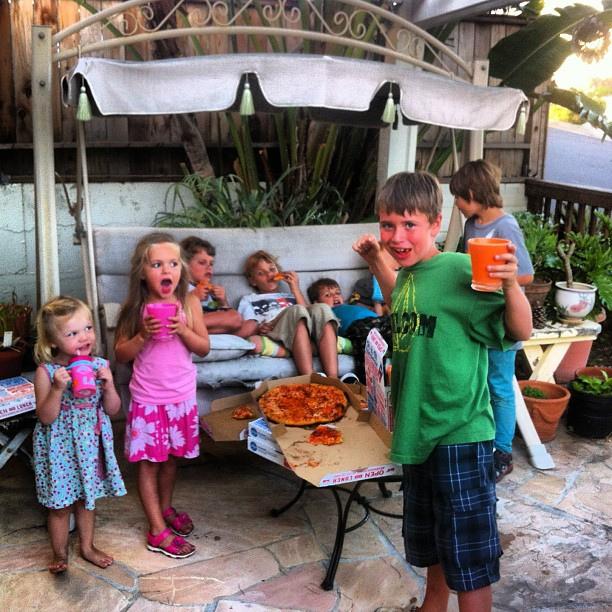What color skirt is the girl wearing?
Write a very short answer. Pink. How many girls are in the picture?
Be succinct. 2. What color is the boys drink?
Write a very short answer. Orange. 